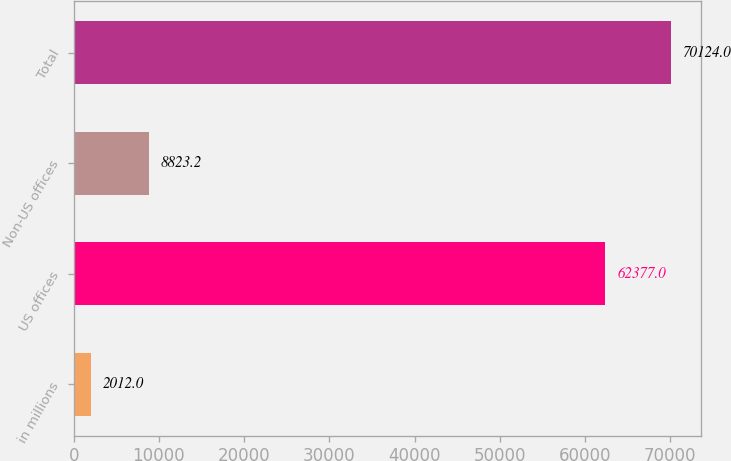<chart> <loc_0><loc_0><loc_500><loc_500><bar_chart><fcel>in millions<fcel>US offices<fcel>Non-US offices<fcel>Total<nl><fcel>2012<fcel>62377<fcel>8823.2<fcel>70124<nl></chart> 